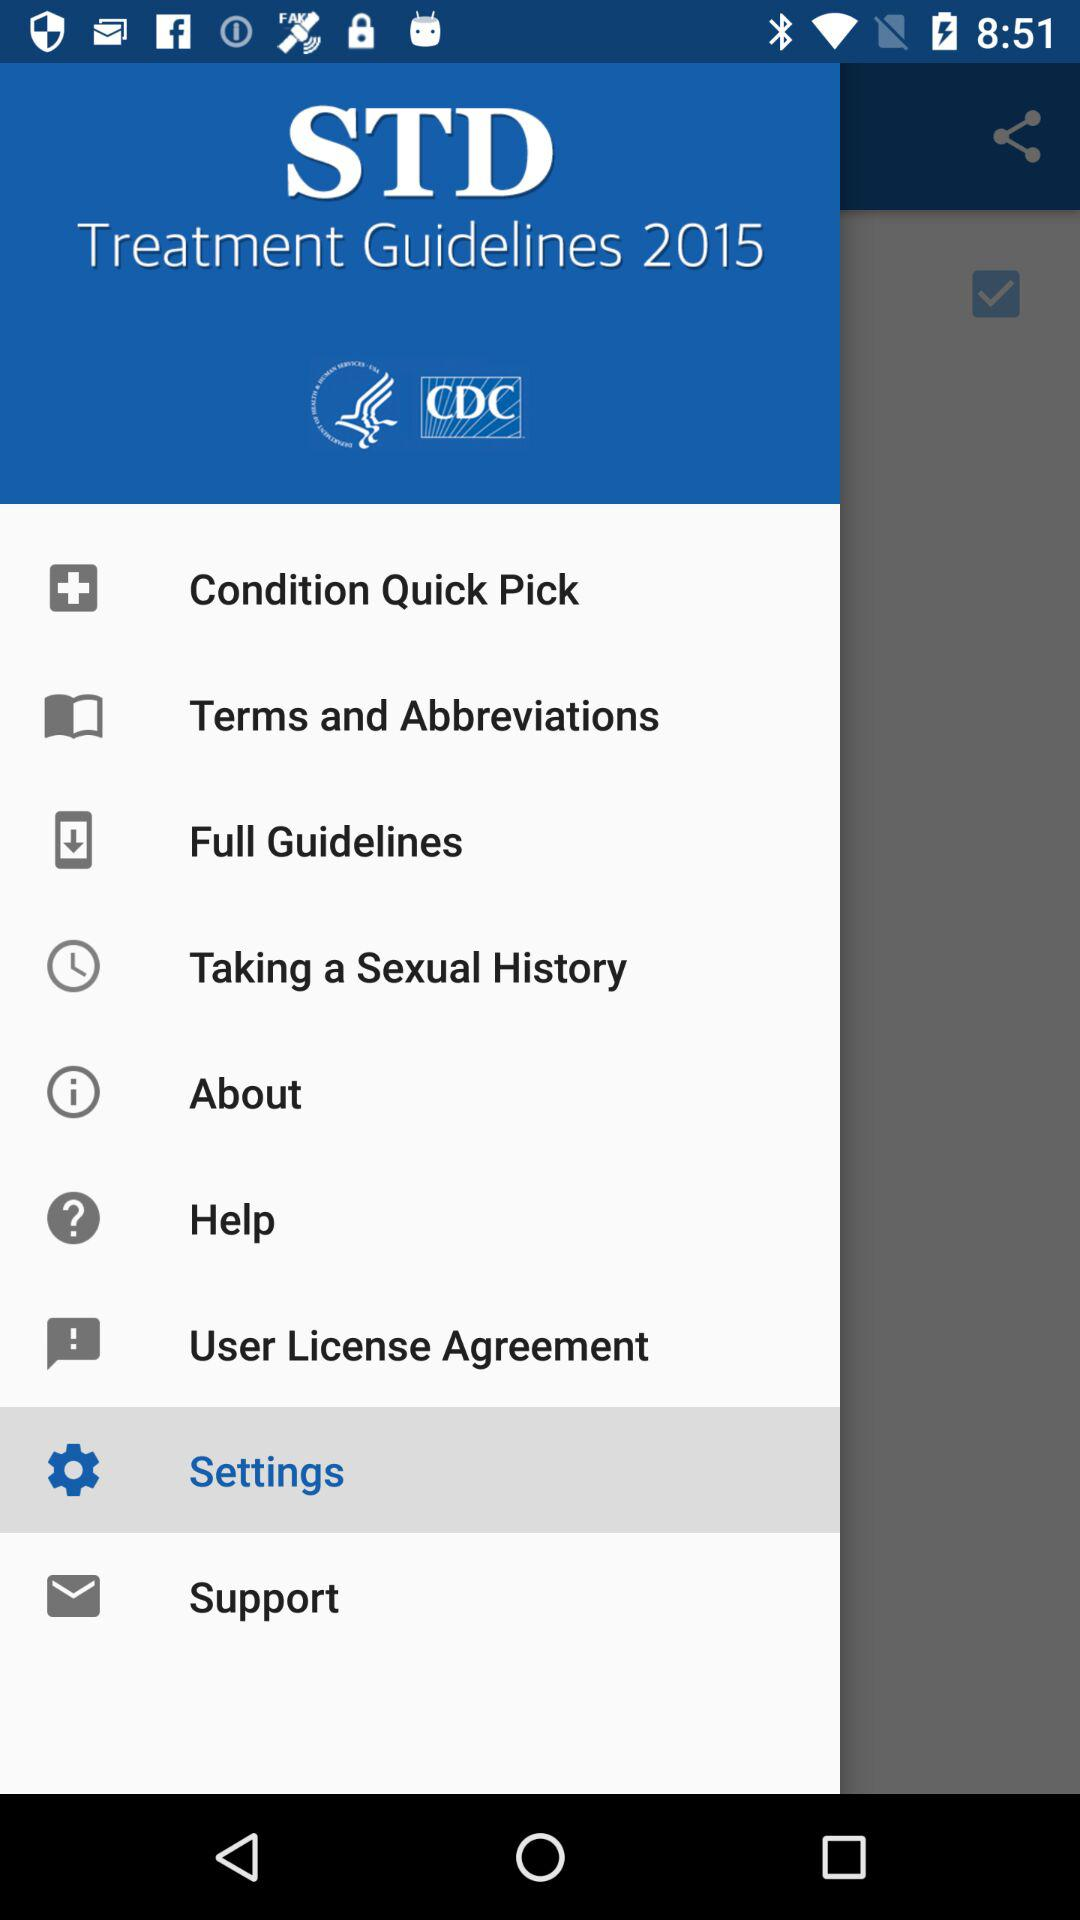What is the application name? The application name is "STD Treatment Guidelines 2015". 